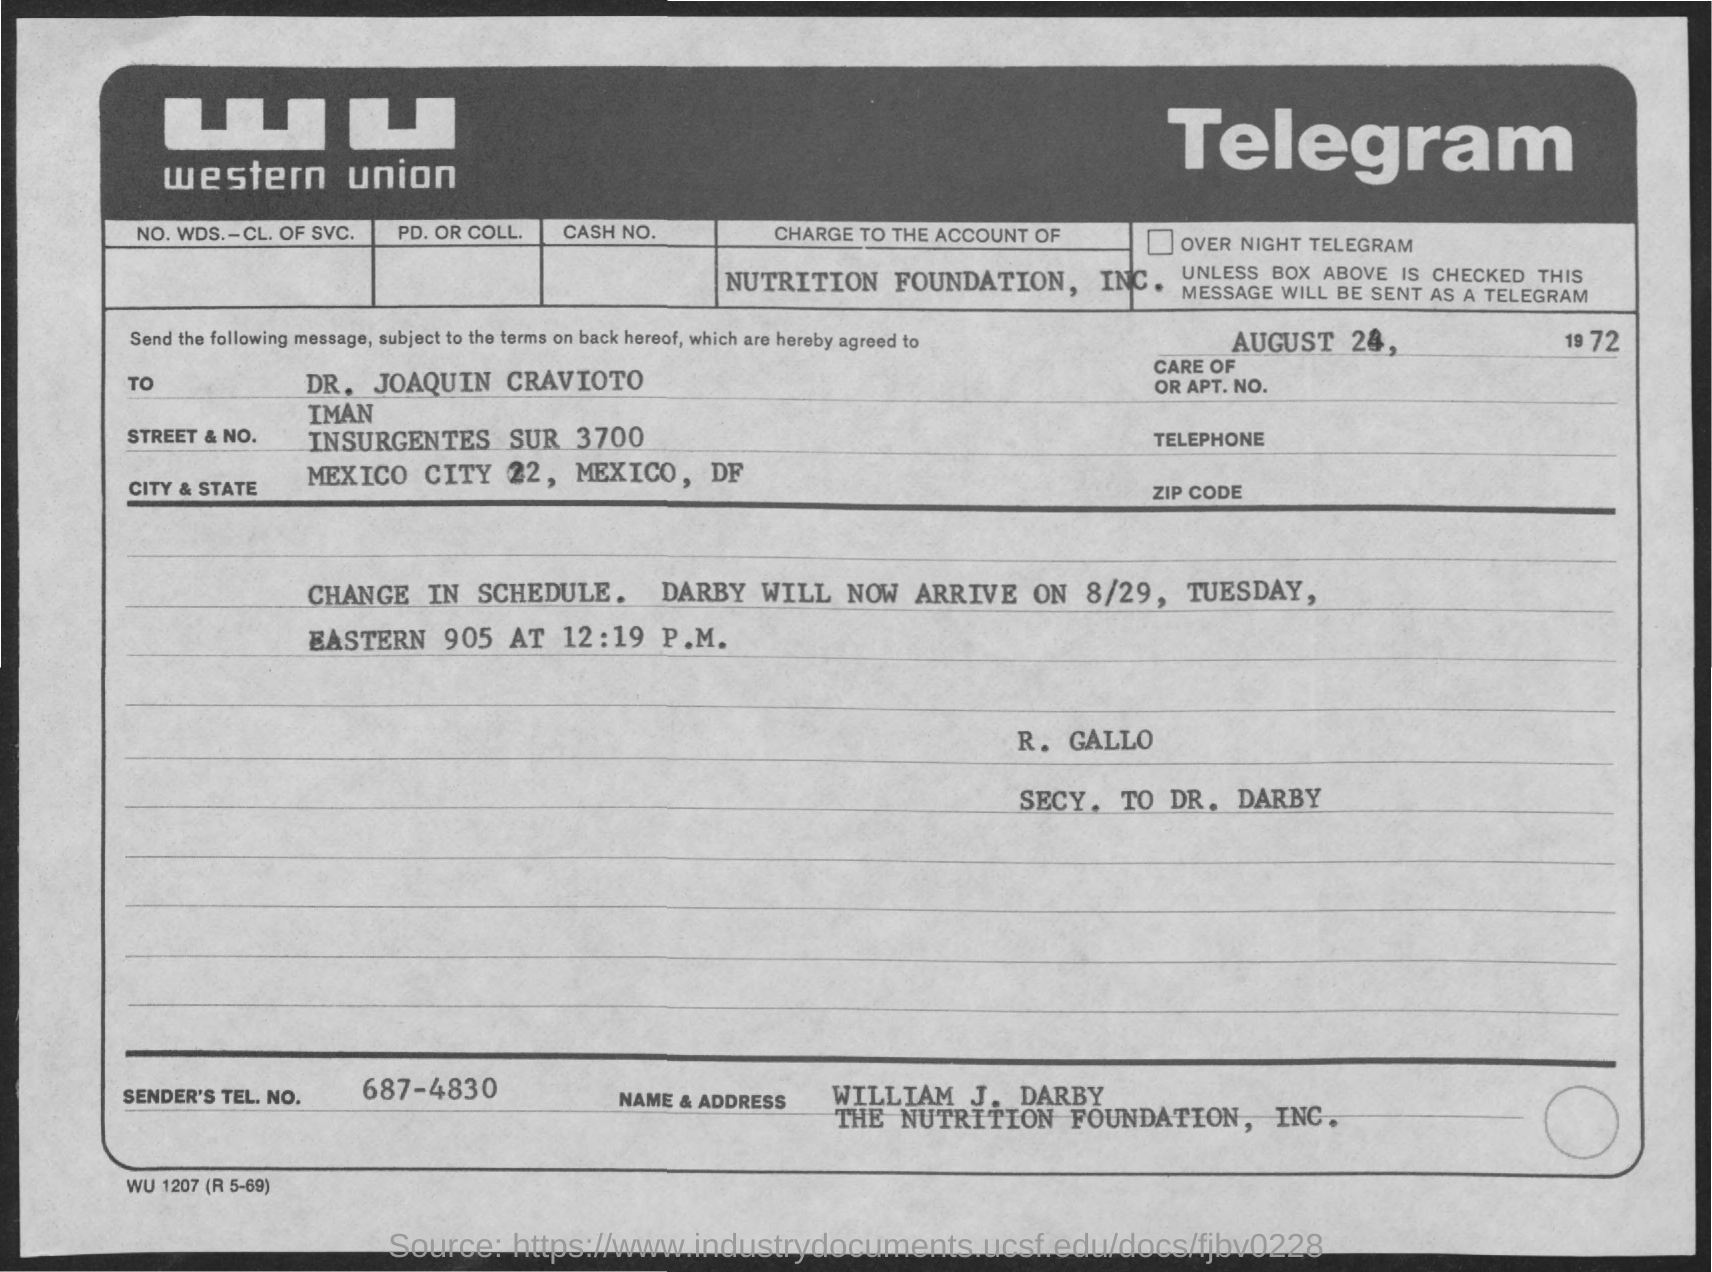Indicate a few pertinent items in this graphic. The date mentioned in the telegram is August 24. The sender's telephone number is 687-4830. The telegram's sender is William J. Darby. 